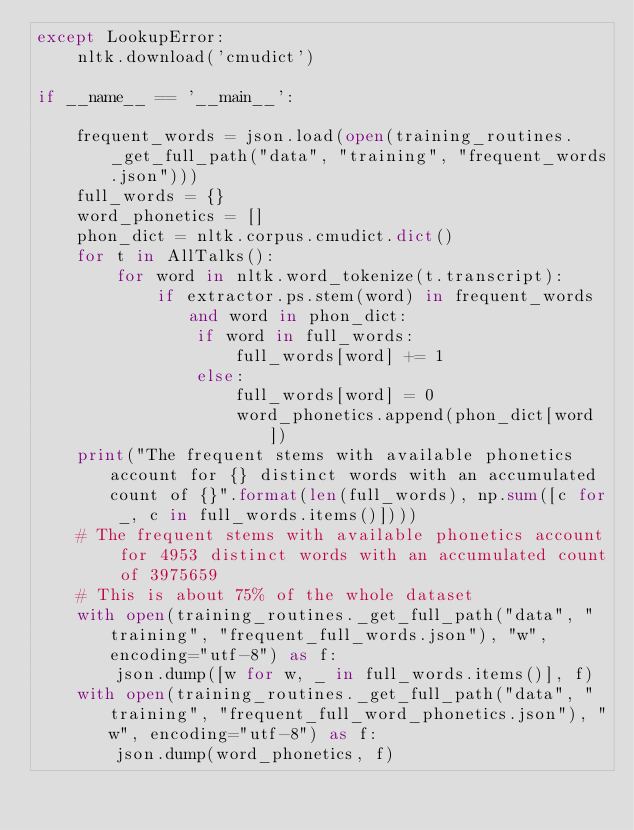<code> <loc_0><loc_0><loc_500><loc_500><_Python_>except LookupError:
	nltk.download('cmudict')

if __name__ == '__main__':
	
	frequent_words = json.load(open(training_routines._get_full_path("data", "training", "frequent_words.json")))
	full_words = {}
	word_phonetics = []
	phon_dict = nltk.corpus.cmudict.dict()
	for t in AllTalks():
		for word in nltk.word_tokenize(t.transcript):
			if extractor.ps.stem(word) in frequent_words and word in phon_dict:
				if word in full_words:
					full_words[word] += 1
				else:
					full_words[word] = 0
					word_phonetics.append(phon_dict[word])
	print("The frequent stems with available phonetics account for {} distinct words with an accumulated count of {}".format(len(full_words), np.sum([c for _, c in full_words.items()])))
	# The frequent stems with available phonetics account for 4953 distinct words with an accumulated count of 3975659
	# This is about 75% of the whole dataset
	with open(training_routines._get_full_path("data", "training", "frequent_full_words.json"), "w", encoding="utf-8") as f:
		json.dump([w for w, _ in full_words.items()], f)
	with open(training_routines._get_full_path("data", "training", "frequent_full_word_phonetics.json"), "w", encoding="utf-8") as f:
		json.dump(word_phonetics, f)
</code> 